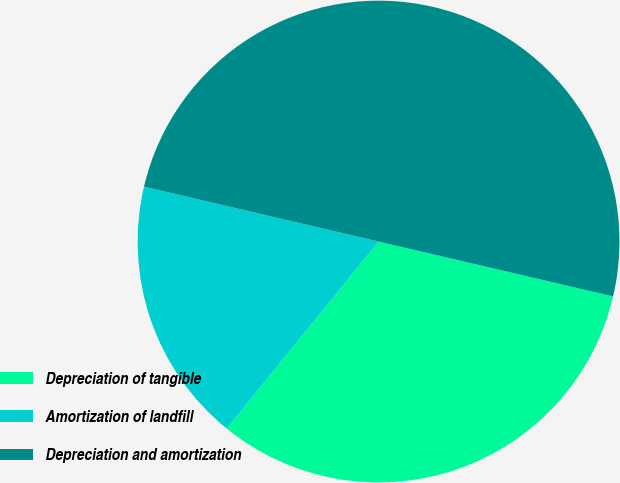Convert chart. <chart><loc_0><loc_0><loc_500><loc_500><pie_chart><fcel>Depreciation of tangible<fcel>Amortization of landfill<fcel>Depreciation and amortization<nl><fcel>32.2%<fcel>17.8%<fcel>50.0%<nl></chart> 